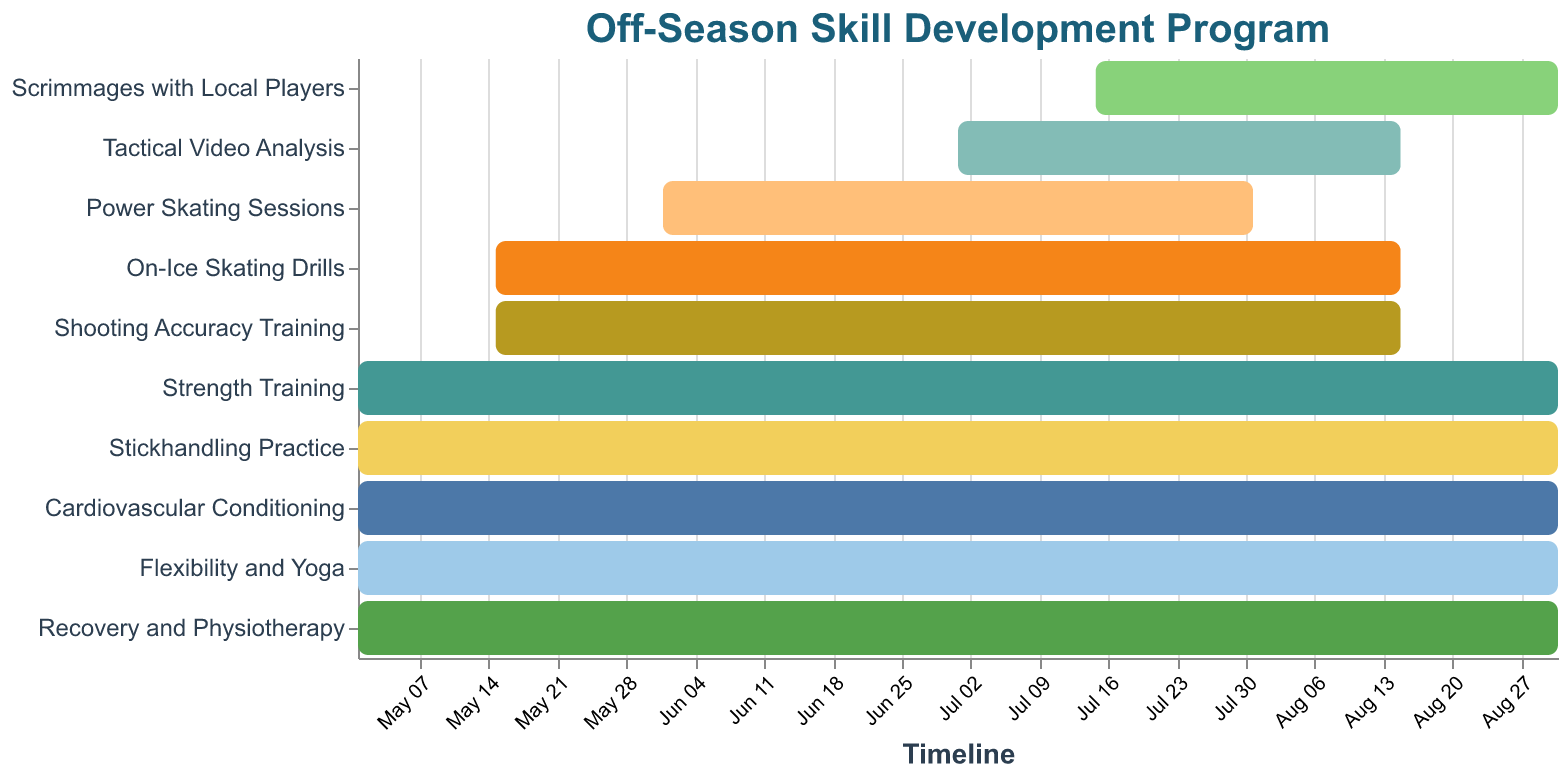What is the duration of the Strength Training task? The Gantt chart shows the tasks with their start and end dates. The Strength Training starts on 2023-05-01 and ends on 2023-08-31, making the duration 123 days.
Answer: 123 days Which task has the shortest duration? By looking at the Gantt chart, the shortest duration task is Tactical Video Analysis, which spans from 2023-07-01 to 2023-08-15, totaling 46 days.
Answer: Tactical Video Analysis Which tasks end exactly on 2023-08-31? Observing the Gantt chart, the tasks that end on 2023-08-31 are Strength Training, Stickhandling Practice, Cardiovascular Conditioning, Flexibility and Yoga, Scrimmages with Local Players, and Recovery and Physiotherapy.
Answer: Strength Training, Stickhandling Practice, Cardiovascular Conditioning, Flexibility and Yoga, Scrimmages with Local Players, Recovery and Physiotherapy What is the total duration of On-Ice Skating Drills and Shooting Accuracy Training combined? On-Ice Skating Drills and Shooting Accuracy Training both start on 2023-05-15 and end on 2023-08-15, each having a duration of 93 days. Combined, their total duration is 93 + 93 = 186 days.
Answer: 186 days Which tasks start in July? From the Gantt chart, the tasks starting in July are Tactical Video Analysis (2023-07-01) and Scrimmages with Local Players (2023-07-15).
Answer: Tactical Video Analysis, Scrimmages with Local Players How many tasks are scheduled to last the entire off-season (from May 1 to August 31)? The tasks that last from May 1 to August 31 (exactly 123 days) are Strength Training, Stickhandling Practice, Cardiovascular Conditioning, Flexibility and Yoga, and Recovery and Physiotherapy.
Answer: Five tasks Which task overlaps the least with the Power Skating Sessions? Power Skating Sessions run from 2023-06-01 to 2023-07-31. The task with the least overlap is Tactical Video Analysis, starting at 2023-07-01 and ending at 2023-08-15, overlapping only for one month from July 1 to July 31.
Answer: Tactical Video Analysis Between Stickhandling Practice and On-Ice Skating Drills, which one has a longer duration? Stickhandling Practice starts on 2023-05-01 and ends on 2023-08-31 spanning 123 days, while On-Ice Skating Drills run from 2023-05-15 to 2023-08-15 spanning 93 days. Therefore, Stickhandling Practice has a longer duration.
Answer: Stickhandling Practice What is the difference in duration between Flexibility and Yoga vs. Power Skating Sessions? Flexibility and Yoga lasts from 2023-05-01 to 2023-08-31, making a total duration of 123 days. The Power Skating Sessions last from 2023-06-01 to 2023-07-31, covering 61 days. The difference in duration is 123 - 61 = 62 days.
Answer: 62 days How many tasks start in May and end in August? The Gantt chart shows that Strength Training, On-Ice Skating Drills, Stickhandling Practice, Shooting Accuracy Training, Cardiovascular Conditioning, Flexibility and Yoga, and Recovery and Physiotherapy start in May and end in August.
Answer: Seven tasks 